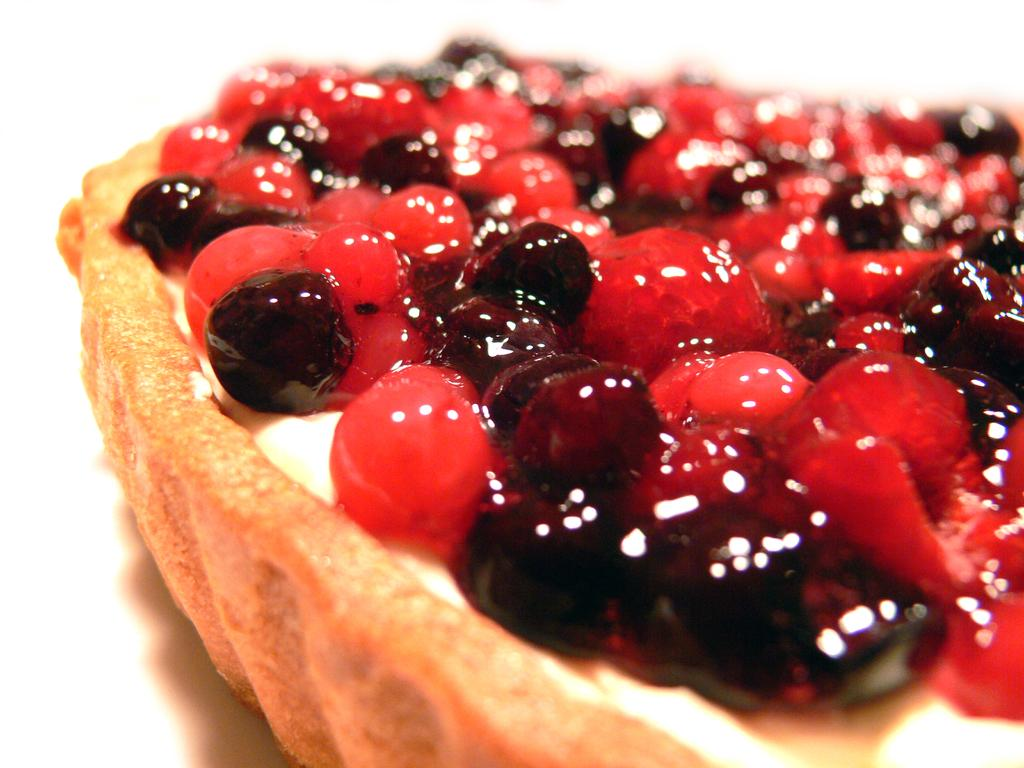What type of fruit is present in the image? There are berries in the image. What type of ornament is hanging from the straw in the image? There is no straw or ornament present in the image; it only features berries. 